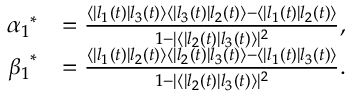Convert formula to latex. <formula><loc_0><loc_0><loc_500><loc_500>\begin{array} { r l } { { \alpha _ { 1 } } ^ { \ast } } & { = \frac { \langle | l _ { 1 } ( t ) | l _ { 3 } ( t ) \rangle \langle | l _ { 3 } ( t ) | l _ { 2 } ( t ) \rangle - \langle | l _ { 1 } ( t ) | l _ { 2 } ( t ) \rangle } { 1 - | \langle | l _ { 2 } ( t ) | l _ { 3 } ( t ) \rangle | ^ { 2 } } , } \\ { { \beta _ { 1 } } ^ { \ast } } & { = \frac { \langle | l _ { 1 } ( t ) | l _ { 2 } ( t ) \rangle \langle | l _ { 2 } ( t ) | l _ { 3 } ( t ) \rangle - \langle | l _ { 1 } ( t ) | l _ { 3 } ( t ) \rangle } { 1 - | \langle | l _ { 2 } ( t ) | l _ { 3 } ( t ) \rangle | ^ { 2 } } . } \end{array}</formula> 